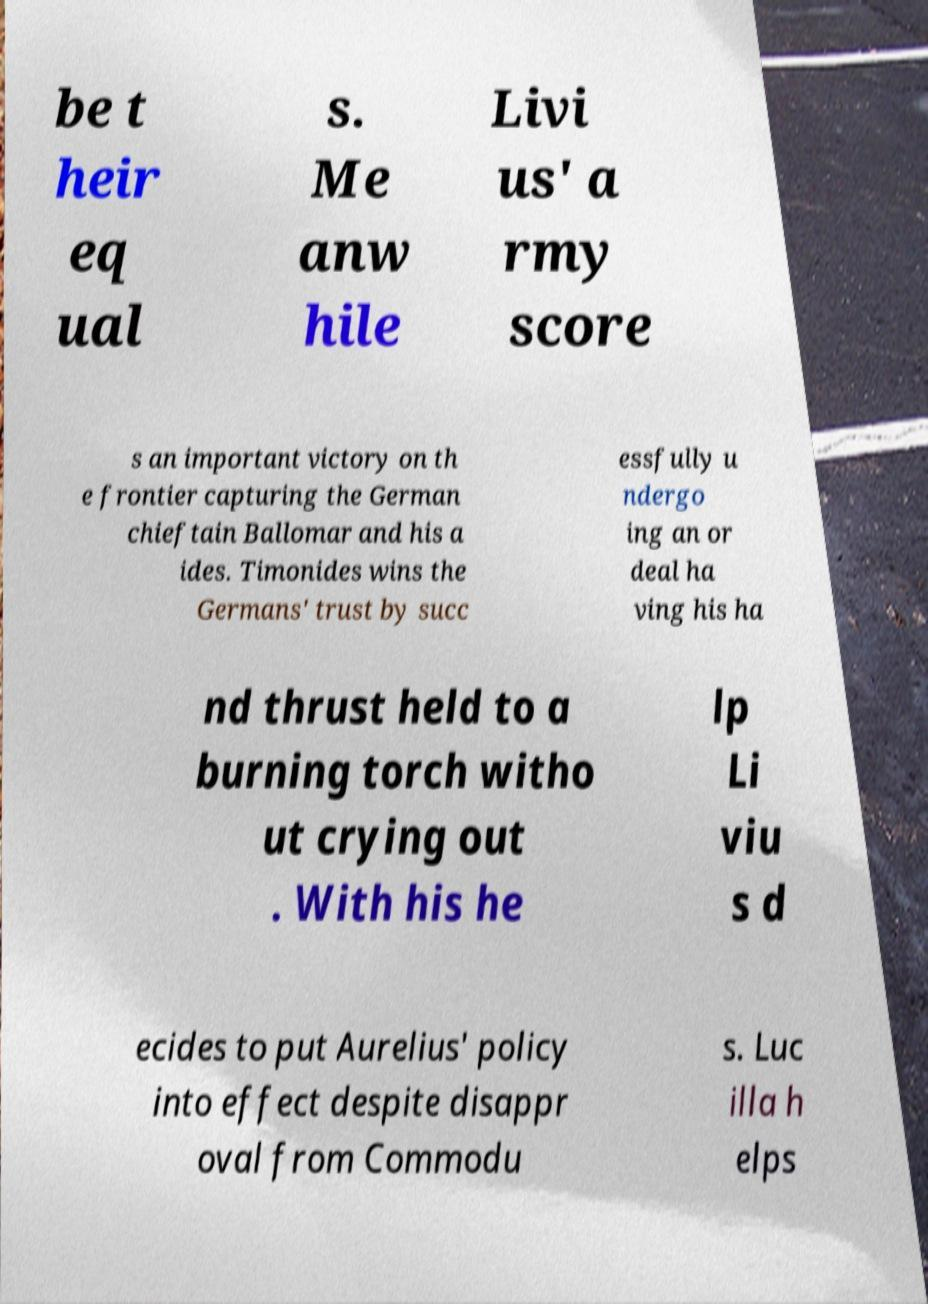Could you extract and type out the text from this image? be t heir eq ual s. Me anw hile Livi us' a rmy score s an important victory on th e frontier capturing the German chieftain Ballomar and his a ides. Timonides wins the Germans' trust by succ essfully u ndergo ing an or deal ha ving his ha nd thrust held to a burning torch witho ut crying out . With his he lp Li viu s d ecides to put Aurelius' policy into effect despite disappr oval from Commodu s. Luc illa h elps 